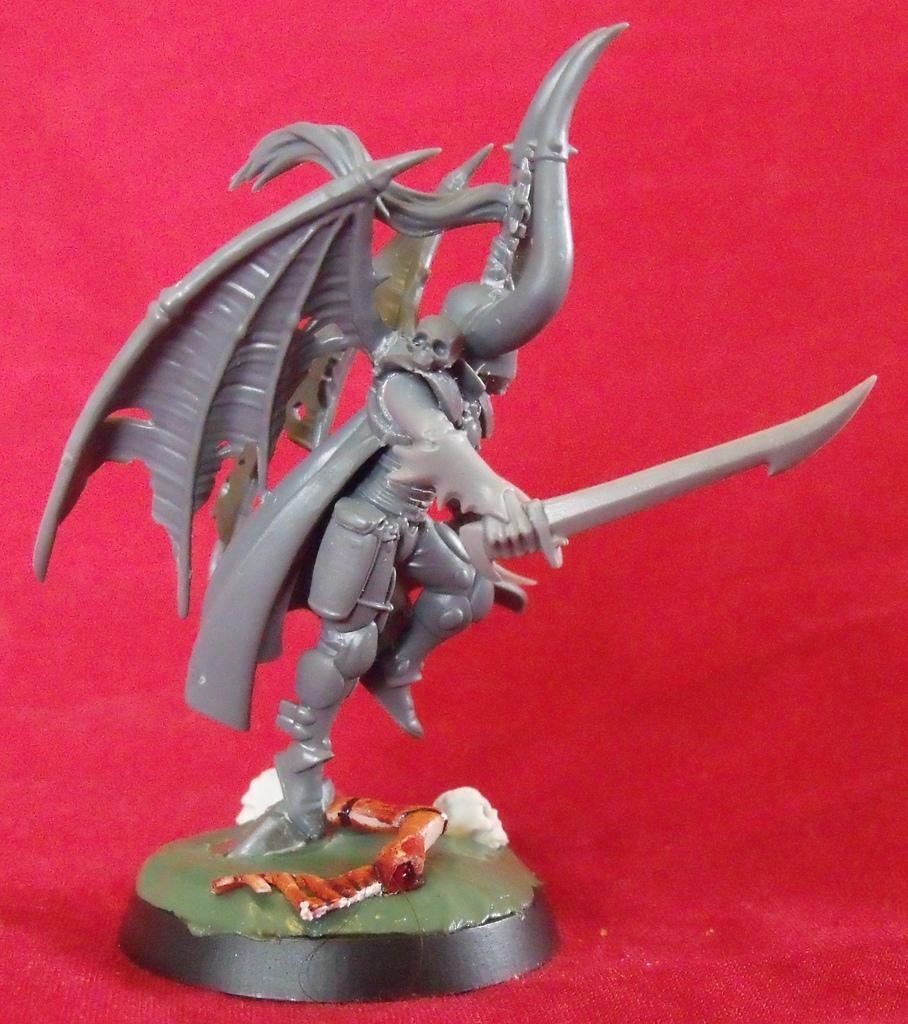What is the main subject in the image? There is a statue in the image. What else can be seen in the image besides the statue? There is a curtain in the image. What color is the curtain? The curtain is red in color. How many scarecrows are present in the image? There are no scarecrows present in the image; it features a statue and a red curtain. What type of birds can be seen flying around the statue in the image? There are no birds present in the image; it only features a statue and a red curtain. 